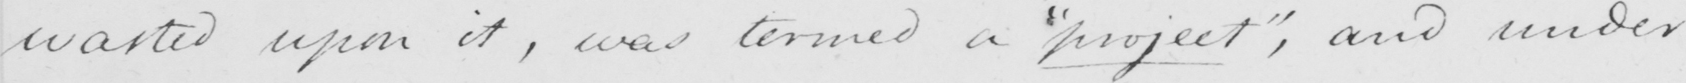Please transcribe the handwritten text in this image. wasted upon it , was termed a  " project "  , and under 